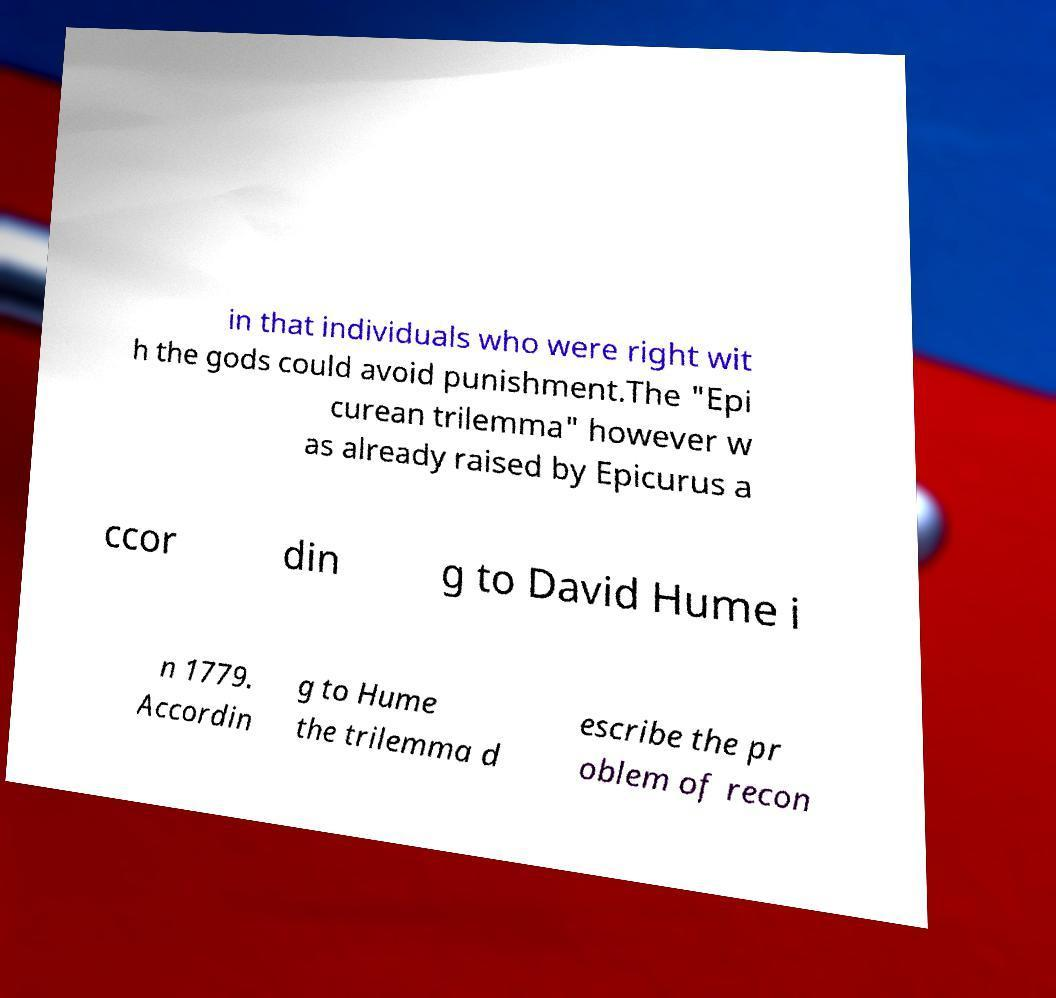Please identify and transcribe the text found in this image. in that individuals who were right wit h the gods could avoid punishment.The "Epi curean trilemma" however w as already raised by Epicurus a ccor din g to David Hume i n 1779. Accordin g to Hume the trilemma d escribe the pr oblem of recon 